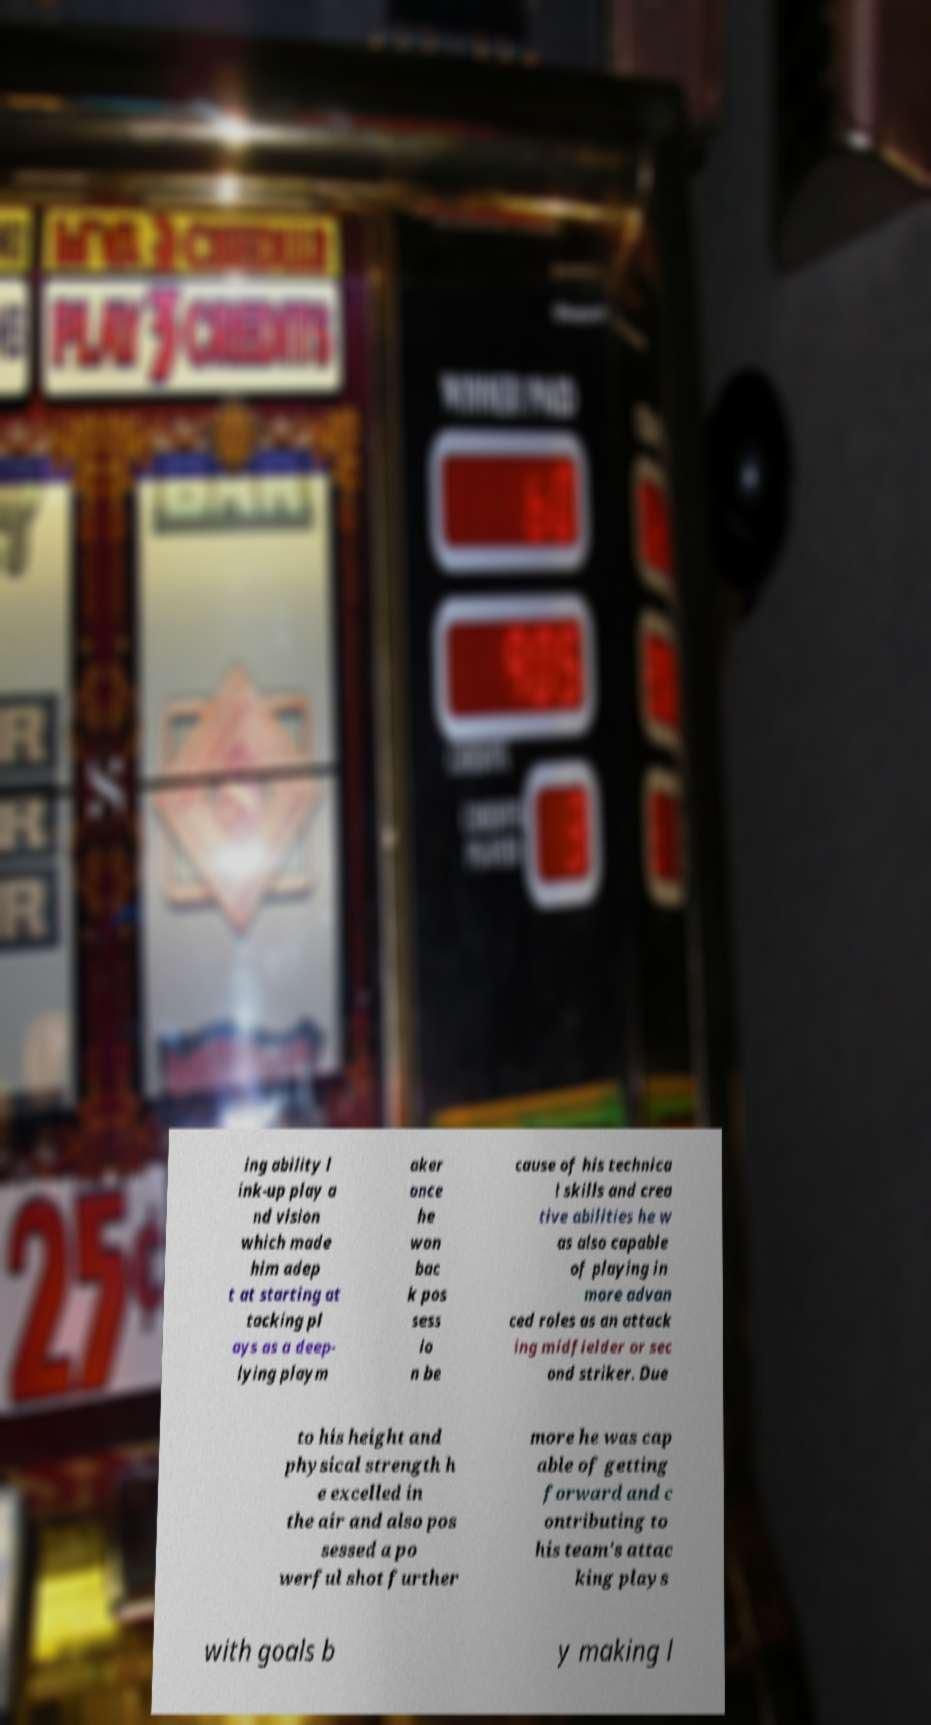Can you accurately transcribe the text from the provided image for me? ing ability l ink-up play a nd vision which made him adep t at starting at tacking pl ays as a deep- lying playm aker once he won bac k pos sess io n be cause of his technica l skills and crea tive abilities he w as also capable of playing in more advan ced roles as an attack ing midfielder or sec ond striker. Due to his height and physical strength h e excelled in the air and also pos sessed a po werful shot further more he was cap able of getting forward and c ontributing to his team's attac king plays with goals b y making l 